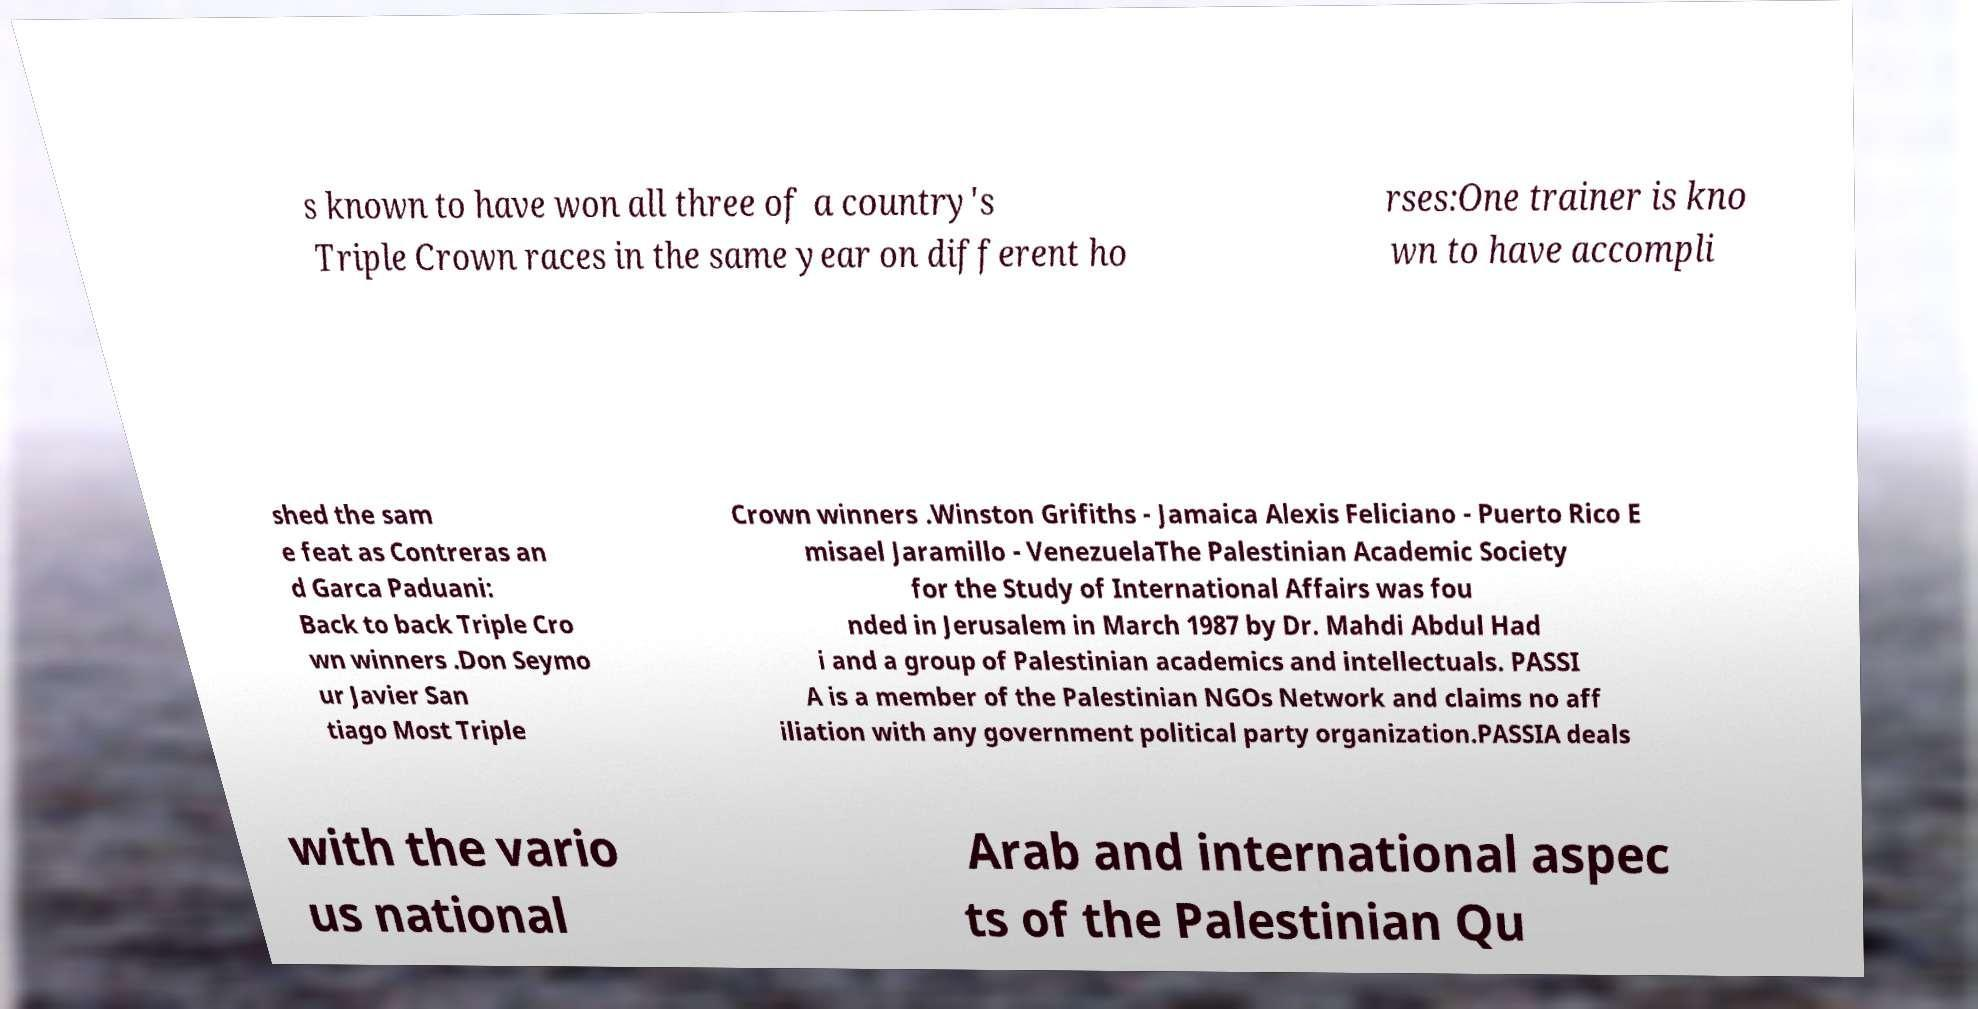Please identify and transcribe the text found in this image. s known to have won all three of a country's Triple Crown races in the same year on different ho rses:One trainer is kno wn to have accompli shed the sam e feat as Contreras an d Garca Paduani: Back to back Triple Cro wn winners .Don Seymo ur Javier San tiago Most Triple Crown winners .Winston Grifiths - Jamaica Alexis Feliciano - Puerto Rico E misael Jaramillo - VenezuelaThe Palestinian Academic Society for the Study of International Affairs was fou nded in Jerusalem in March 1987 by Dr. Mahdi Abdul Had i and a group of Palestinian academics and intellectuals. PASSI A is a member of the Palestinian NGOs Network and claims no aff iliation with any government political party organization.PASSIA deals with the vario us national Arab and international aspec ts of the Palestinian Qu 